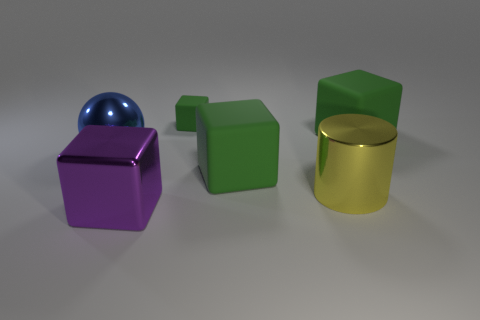Subtract all large blocks. How many blocks are left? 1 Add 1 large yellow cylinders. How many objects exist? 7 Subtract 3 cubes. How many cubes are left? 1 Subtract all cylinders. How many objects are left? 5 Subtract all green blocks. How many blocks are left? 1 Subtract all yellow spheres. How many green cubes are left? 3 Subtract all blue objects. Subtract all metal objects. How many objects are left? 2 Add 4 small things. How many small things are left? 5 Add 1 small things. How many small things exist? 2 Subtract 0 cyan spheres. How many objects are left? 6 